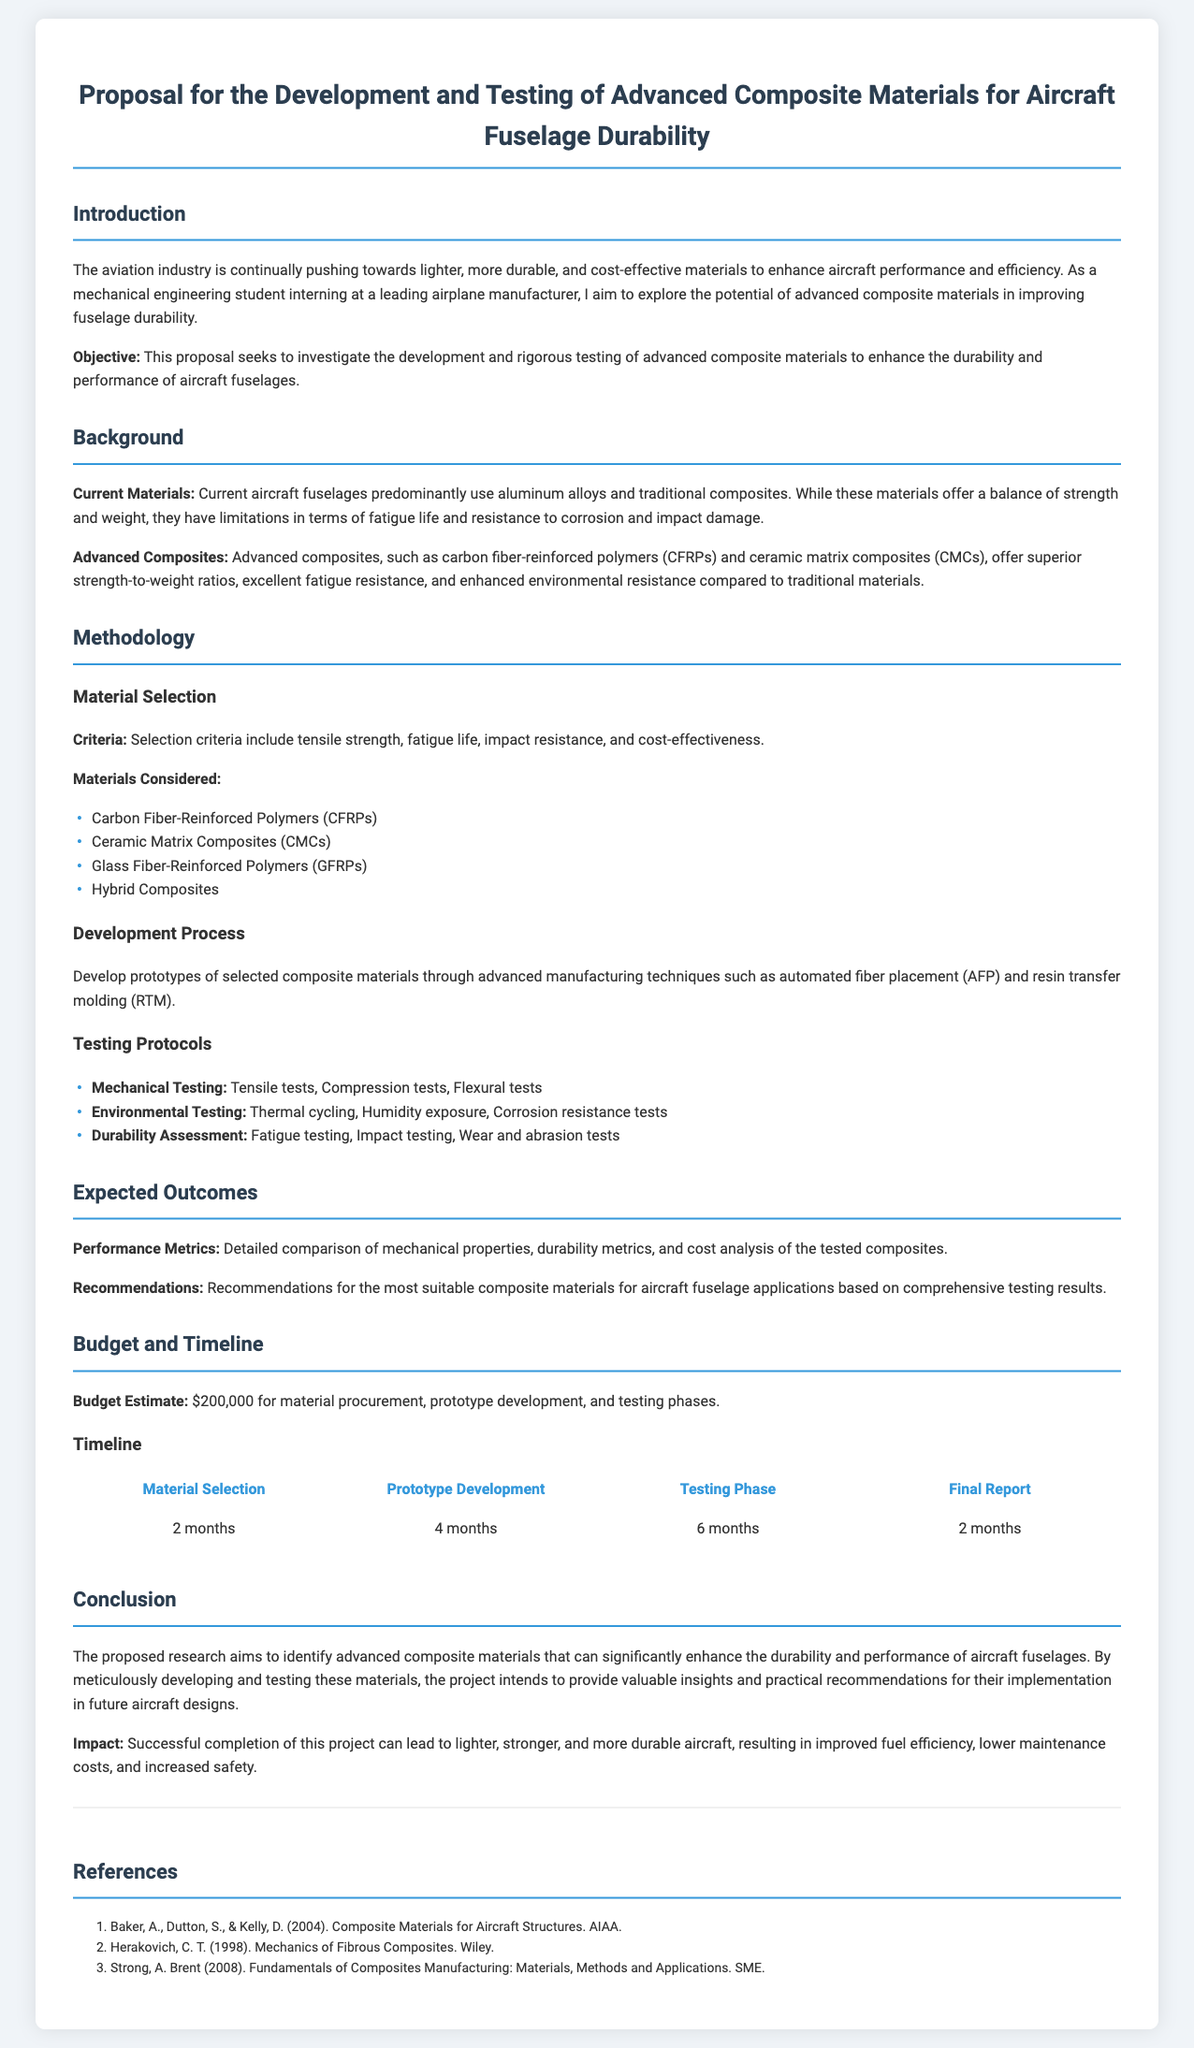what is the budget estimate for the project? The budget estimate is stated in the Budget and Timeline section, which includes costs for material procurement, prototype development, and testing phases.
Answer: $200,000 how long is the prototype development phase? The timeline illustrates the duration allocated for each phase, stating that prototype development lasts four months.
Answer: 4 months what are the advanced composite materials considered in this proposal? The methodology section lists the advanced composite materials under Material Selection, indicating all materials being investigated for the development and testing process.
Answer: Carbon Fiber-Reinforced Polymers, Ceramic Matrix Composites, Glass Fiber-Reinforced Polymers, Hybrid Composites what kind of testing will be performed on the materials? The Testing Protocols section outlines the types of tests that will be conducted, detailing specific tests for each category.
Answer: Mechanical Testing, Environmental Testing, Durability Assessment what is the expected impact of the successful completion of this project? The conclusion describes the potential outcomes and advantages of the research, specifically looking at the benefits to aircraft performance and cost.
Answer: Improved fuel efficiency, lower maintenance costs, increased safety which composite material offers superior strength-to-weight ratios? The Background section specifies that advanced composites, particularly certain types, provide improved strength-to-weight ratios compared to traditional materials.
Answer: Advanced composites how many months will the final report take to complete? The timeline in the Budget and Timeline section clearly indicates the duration allocated for the final report.
Answer: 2 months 